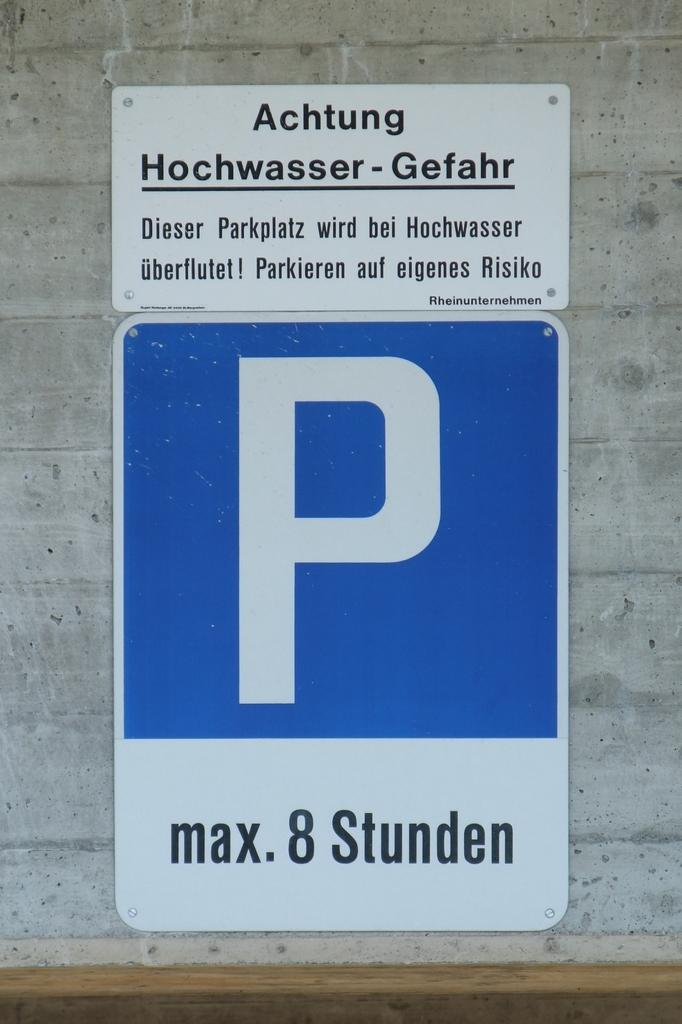<image>
Present a compact description of the photo's key features. A blue parking sign on a building in another language. 